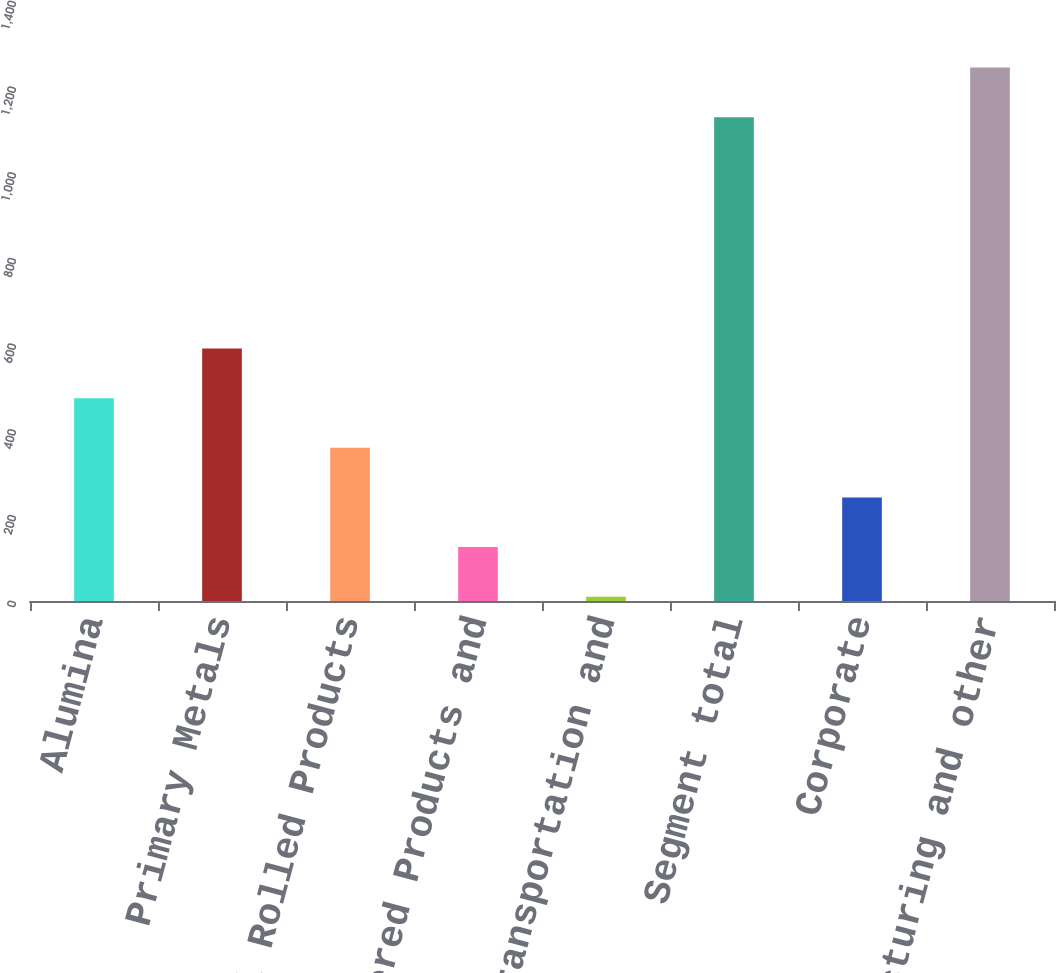Convert chart. <chart><loc_0><loc_0><loc_500><loc_500><bar_chart><fcel>Alumina<fcel>Primary Metals<fcel>Global Rolled Products<fcel>Engineered Products and<fcel>Transportation and<fcel>Segment total<fcel>Corporate<fcel>Total restructuring and other<nl><fcel>473.2<fcel>589<fcel>357.4<fcel>125.8<fcel>10<fcel>1129<fcel>241.6<fcel>1244.8<nl></chart> 